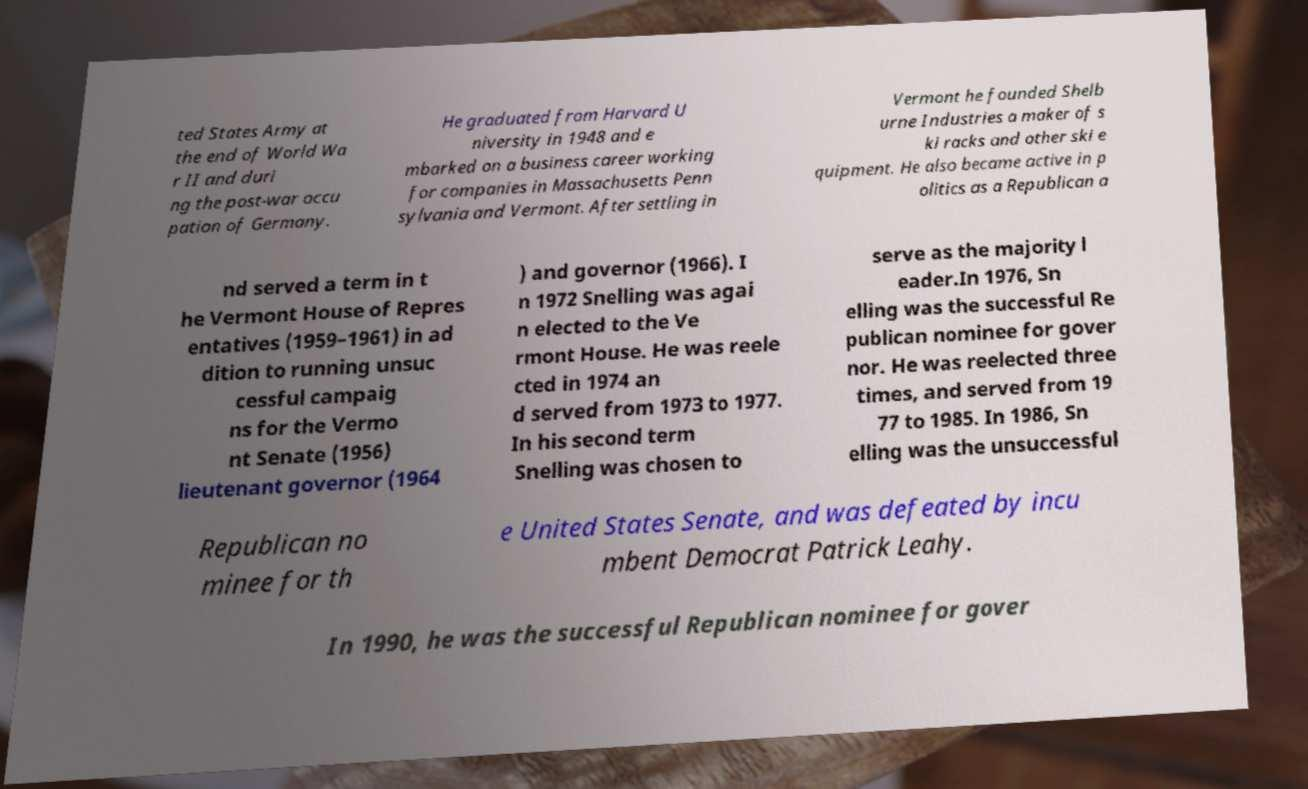Please identify and transcribe the text found in this image. ted States Army at the end of World Wa r II and duri ng the post-war occu pation of Germany. He graduated from Harvard U niversity in 1948 and e mbarked on a business career working for companies in Massachusetts Penn sylvania and Vermont. After settling in Vermont he founded Shelb urne Industries a maker of s ki racks and other ski e quipment. He also became active in p olitics as a Republican a nd served a term in t he Vermont House of Repres entatives (1959–1961) in ad dition to running unsuc cessful campaig ns for the Vermo nt Senate (1956) lieutenant governor (1964 ) and governor (1966). I n 1972 Snelling was agai n elected to the Ve rmont House. He was reele cted in 1974 an d served from 1973 to 1977. In his second term Snelling was chosen to serve as the majority l eader.In 1976, Sn elling was the successful Re publican nominee for gover nor. He was reelected three times, and served from 19 77 to 1985. In 1986, Sn elling was the unsuccessful Republican no minee for th e United States Senate, and was defeated by incu mbent Democrat Patrick Leahy. In 1990, he was the successful Republican nominee for gover 